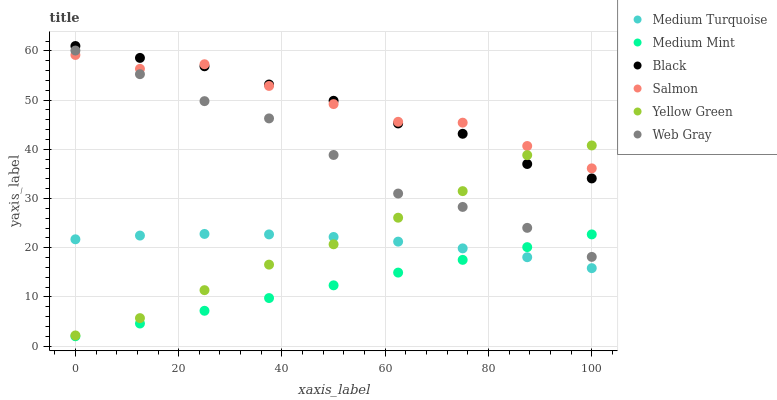Does Medium Mint have the minimum area under the curve?
Answer yes or no. Yes. Does Salmon have the maximum area under the curve?
Answer yes or no. Yes. Does Web Gray have the minimum area under the curve?
Answer yes or no. No. Does Web Gray have the maximum area under the curve?
Answer yes or no. No. Is Medium Mint the smoothest?
Answer yes or no. Yes. Is Salmon the roughest?
Answer yes or no. Yes. Is Web Gray the smoothest?
Answer yes or no. No. Is Web Gray the roughest?
Answer yes or no. No. Does Medium Mint have the lowest value?
Answer yes or no. Yes. Does Web Gray have the lowest value?
Answer yes or no. No. Does Black have the highest value?
Answer yes or no. Yes. Does Web Gray have the highest value?
Answer yes or no. No. Is Medium Mint less than Yellow Green?
Answer yes or no. Yes. Is Black greater than Medium Turquoise?
Answer yes or no. Yes. Does Yellow Green intersect Medium Turquoise?
Answer yes or no. Yes. Is Yellow Green less than Medium Turquoise?
Answer yes or no. No. Is Yellow Green greater than Medium Turquoise?
Answer yes or no. No. Does Medium Mint intersect Yellow Green?
Answer yes or no. No. 